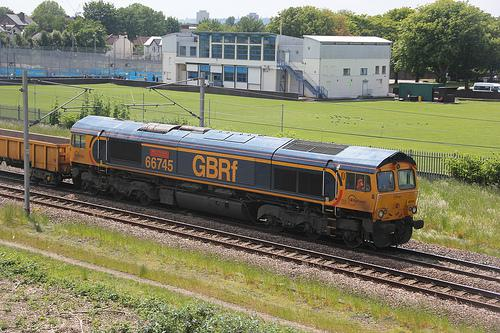Question: what color is the sky?
Choices:
A. White.
B. Blue.
C. Gray.
D. Green.
Answer with the letter. Answer: C Question: how many tracks are there?
Choices:
A. One.
B. Three.
C. Four.
D. Two.
Answer with the letter. Answer: D Question: how many trains are there?
Choices:
A. Two.
B. Four.
C. One.
D. Eight.
Answer with the letter. Answer: C 